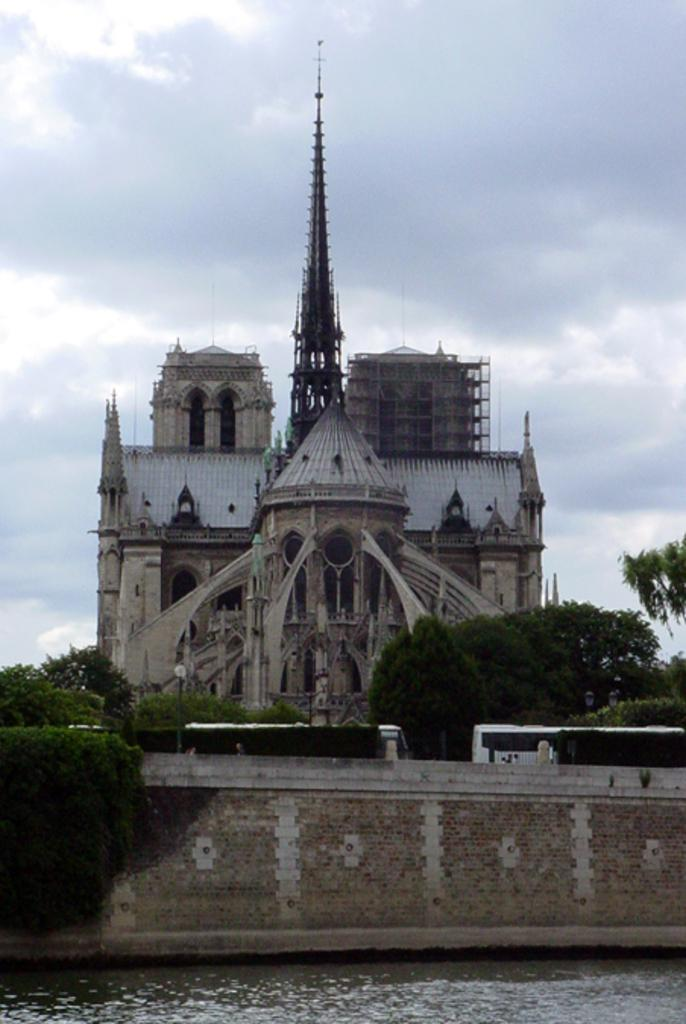What type of structures can be seen in the image? There are buildings in the image. What part of the buildings can be seen through the windows? Windows are visible in the image, but the conversation should focus on the structures themselves, not what can be seen through them. What type of vegetation is present in the image? There are trees in the image. What natural element is visible in the image? There is water visible in the image. What type of transportation is present in the image? There are vehicles in the image. What architectural feature can be seen in the image? There is a wall in the image. What part of the natural environment is visible in the image? The sky is visible in the image. Can you tell me how many women are giving birth in the scene depicted in the image? There is no scene of women giving birth present in the image; it features buildings, windows, trees, water, vehicles, a wall, and the sky. What type of woman is shown interacting with the water in the image? There is no woman present in the image; it features buildings, windows, trees, water, vehicles, a wall, and the sky. 